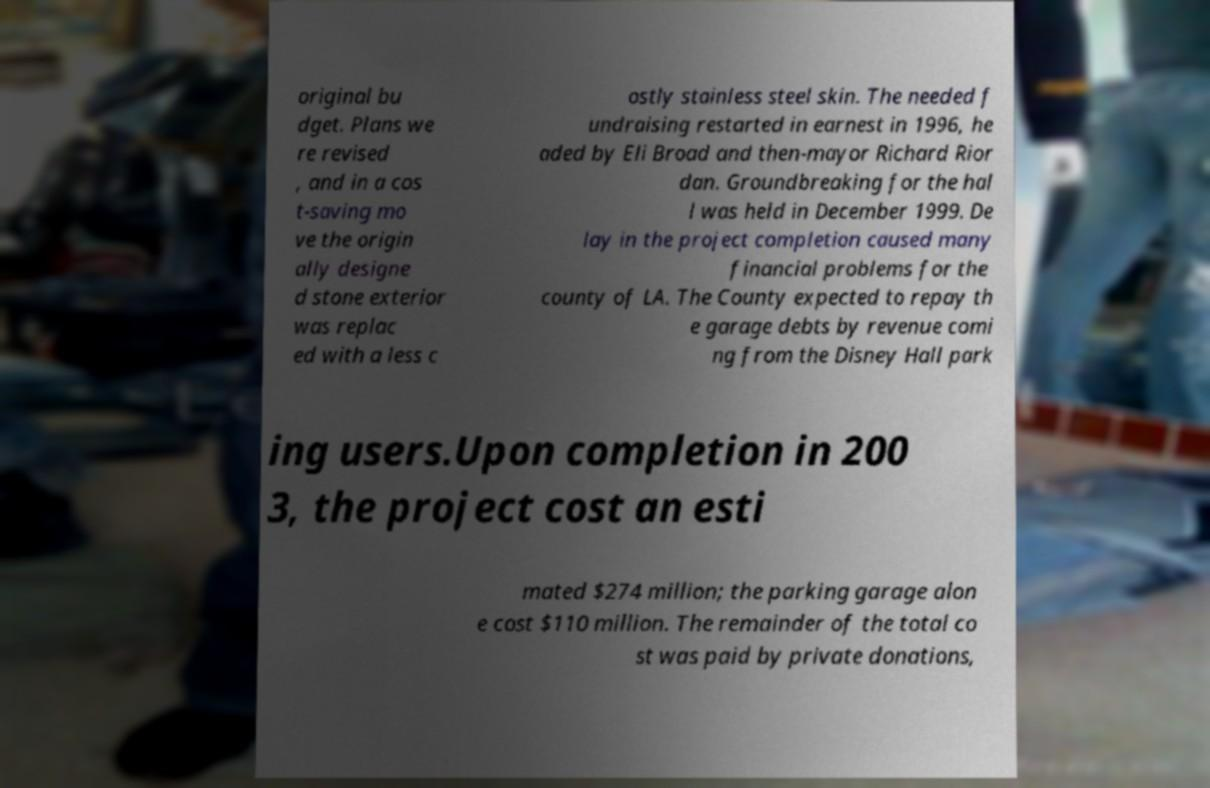What messages or text are displayed in this image? I need them in a readable, typed format. original bu dget. Plans we re revised , and in a cos t-saving mo ve the origin ally designe d stone exterior was replac ed with a less c ostly stainless steel skin. The needed f undraising restarted in earnest in 1996, he aded by Eli Broad and then-mayor Richard Rior dan. Groundbreaking for the hal l was held in December 1999. De lay in the project completion caused many financial problems for the county of LA. The County expected to repay th e garage debts by revenue comi ng from the Disney Hall park ing users.Upon completion in 200 3, the project cost an esti mated $274 million; the parking garage alon e cost $110 million. The remainder of the total co st was paid by private donations, 